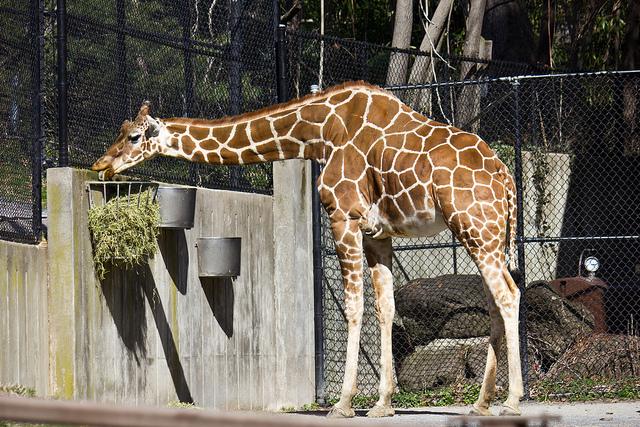What animal is this?
Write a very short answer. Giraffe. Is the animal short?
Concise answer only. No. Is the animal eating?
Quick response, please. Yes. 